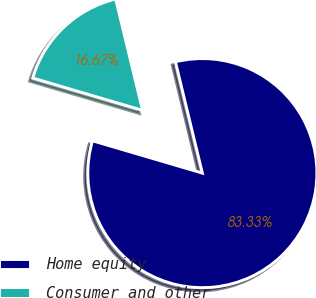Convert chart. <chart><loc_0><loc_0><loc_500><loc_500><pie_chart><fcel>Home equity<fcel>Consumer and other<nl><fcel>83.33%<fcel>16.67%<nl></chart> 